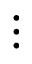Convert formula to latex. <formula><loc_0><loc_0><loc_500><loc_500>\vdots</formula> 